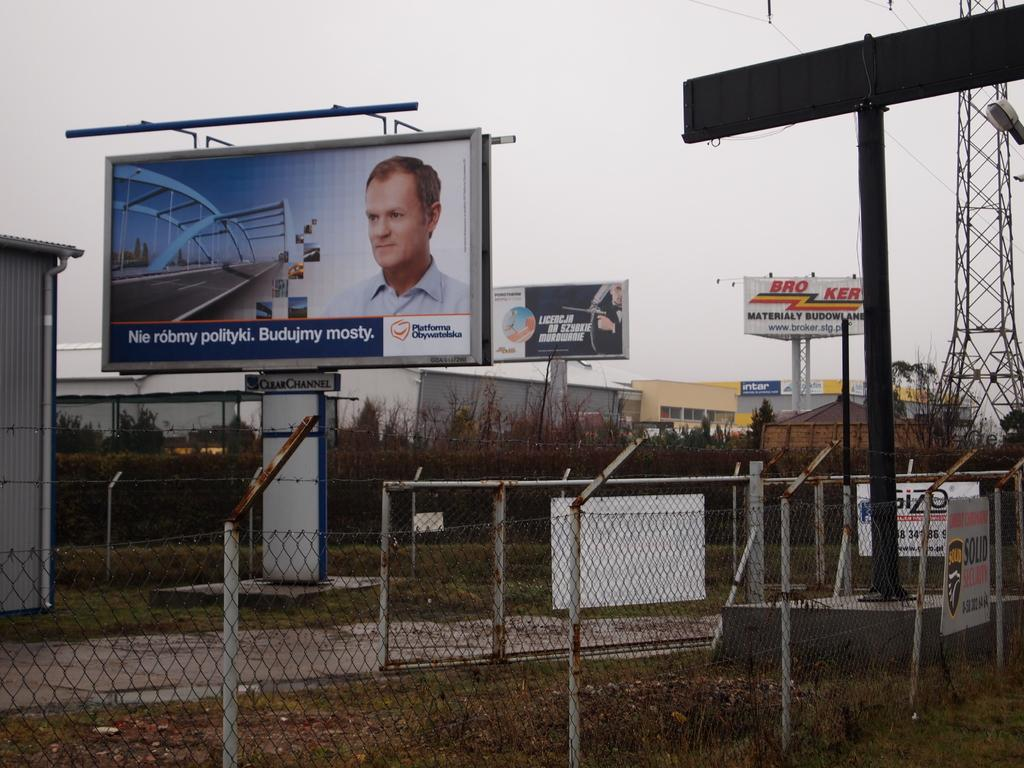Provide a one-sentence caption for the provided image. Several foreign language billboards are standing behind a chain link fence. 